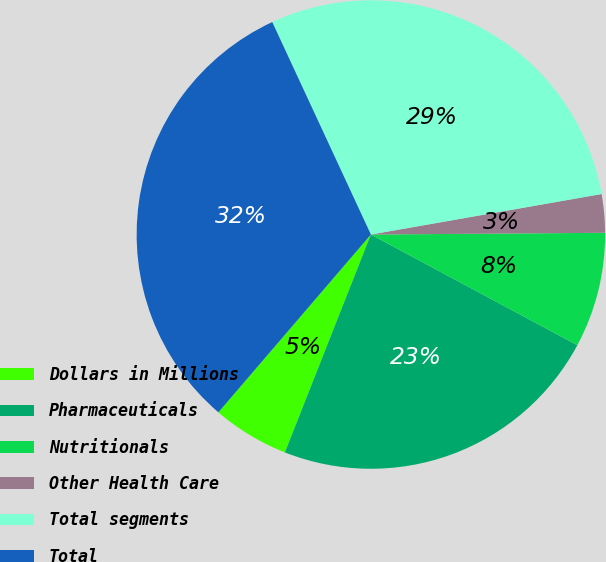Convert chart to OTSL. <chart><loc_0><loc_0><loc_500><loc_500><pie_chart><fcel>Dollars in Millions<fcel>Pharmaceuticals<fcel>Nutritionals<fcel>Other Health Care<fcel>Total segments<fcel>Total<nl><fcel>5.3%<fcel>23.15%<fcel>7.95%<fcel>2.65%<fcel>29.15%<fcel>31.8%<nl></chart> 